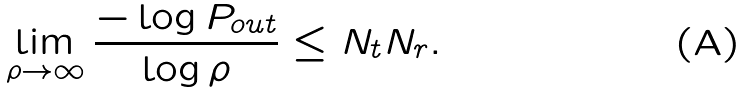Convert formula to latex. <formula><loc_0><loc_0><loc_500><loc_500>\lim _ { \rho \rightarrow \infty } \frac { - \log P _ { o u t } } { \log \rho } \leq N _ { t } N _ { r } .</formula> 